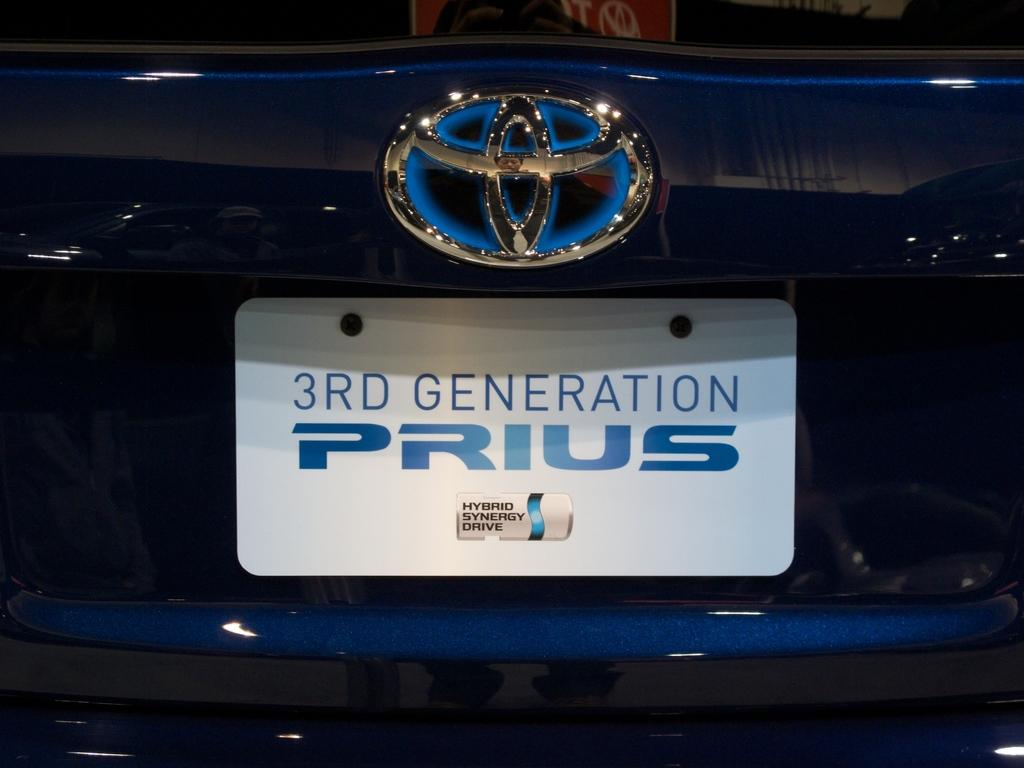<image>
Give a short and clear explanation of the subsequent image. a 3rd generation prius with a label above it 